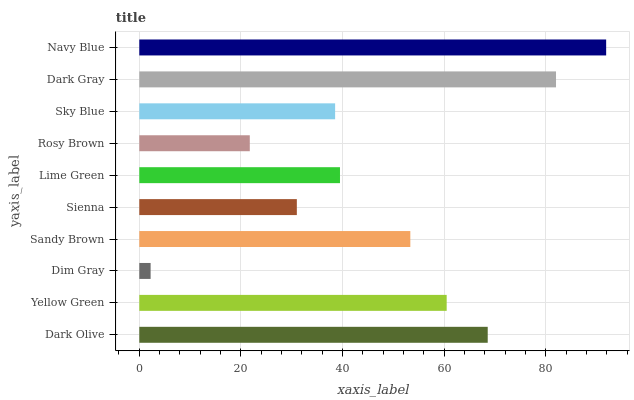Is Dim Gray the minimum?
Answer yes or no. Yes. Is Navy Blue the maximum?
Answer yes or no. Yes. Is Yellow Green the minimum?
Answer yes or no. No. Is Yellow Green the maximum?
Answer yes or no. No. Is Dark Olive greater than Yellow Green?
Answer yes or no. Yes. Is Yellow Green less than Dark Olive?
Answer yes or no. Yes. Is Yellow Green greater than Dark Olive?
Answer yes or no. No. Is Dark Olive less than Yellow Green?
Answer yes or no. No. Is Sandy Brown the high median?
Answer yes or no. Yes. Is Lime Green the low median?
Answer yes or no. Yes. Is Sienna the high median?
Answer yes or no. No. Is Rosy Brown the low median?
Answer yes or no. No. 